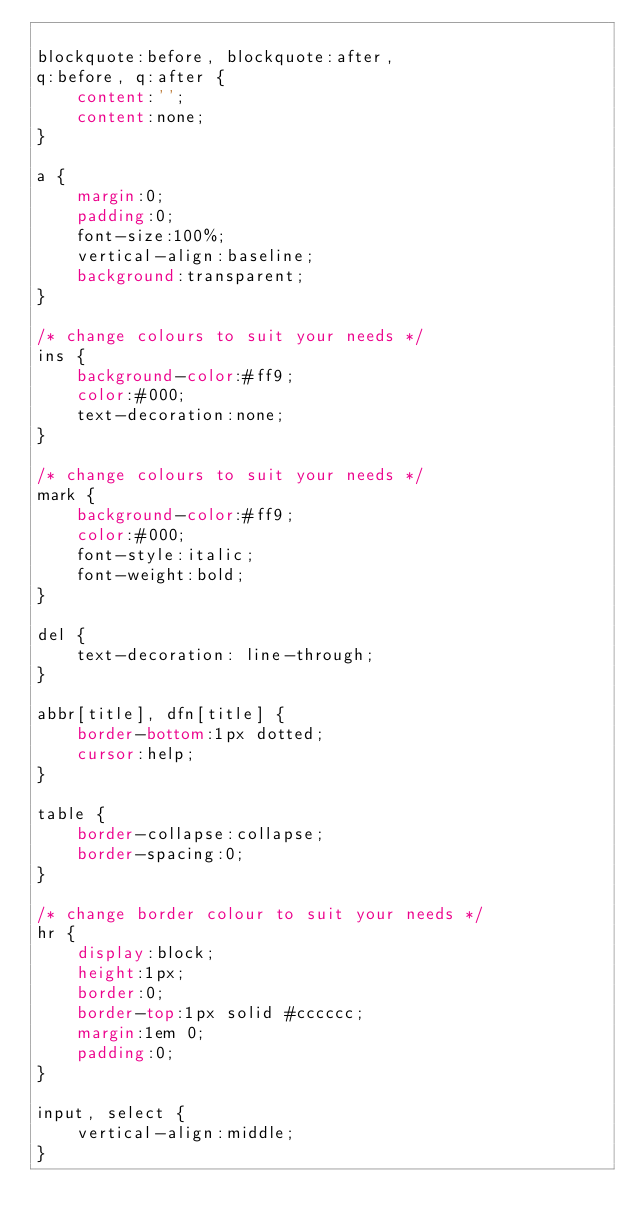Convert code to text. <code><loc_0><loc_0><loc_500><loc_500><_CSS_> 
blockquote:before, blockquote:after,
q:before, q:after {
    content:'';
    content:none;
}
 
a {
    margin:0;
    padding:0;
    font-size:100%;
    vertical-align:baseline;
    background:transparent;
}
 
/* change colours to suit your needs */
ins {
    background-color:#ff9;
    color:#000;
    text-decoration:none;
}
 
/* change colours to suit your needs */
mark {
    background-color:#ff9;
    color:#000;
    font-style:italic;
    font-weight:bold;
}
 
del {
    text-decoration: line-through;
}
 
abbr[title], dfn[title] {
    border-bottom:1px dotted;
    cursor:help;
}
 
table {
    border-collapse:collapse;
    border-spacing:0;
}
 
/* change border colour to suit your needs */
hr {
    display:block;
    height:1px;
    border:0;  
    border-top:1px solid #cccccc;
    margin:1em 0;
    padding:0;
}
 
input, select {
    vertical-align:middle;
}
</code> 